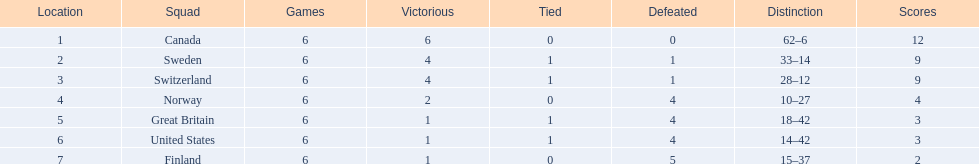What are the names of the countries? Canada, Sweden, Switzerland, Norway, Great Britain, United States, Finland. Parse the full table in json format. {'header': ['Location', 'Squad', 'Games', 'Victorious', 'Tied', 'Defeated', 'Distinction', 'Scores'], 'rows': [['1', 'Canada', '6', '6', '0', '0', '62–6', '12'], ['2', 'Sweden', '6', '4', '1', '1', '33–14', '9'], ['3', 'Switzerland', '6', '4', '1', '1', '28–12', '9'], ['4', 'Norway', '6', '2', '0', '4', '10–27', '4'], ['5', 'Great Britain', '6', '1', '1', '4', '18–42', '3'], ['6', 'United States', '6', '1', '1', '4', '14–42', '3'], ['7', 'Finland', '6', '1', '0', '5', '15–37', '2']]} How many wins did switzerland have? 4. How many wins did great britain have? 1. Which country had more wins, great britain or switzerland? Switzerland. 